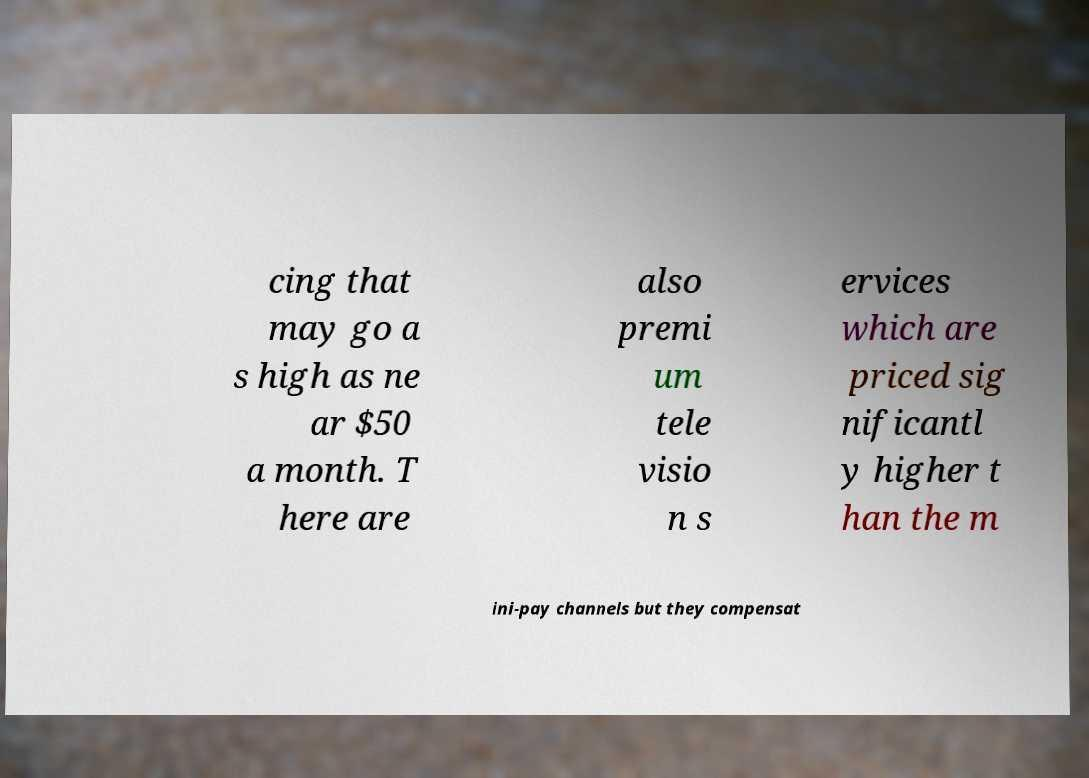Could you assist in decoding the text presented in this image and type it out clearly? cing that may go a s high as ne ar $50 a month. T here are also premi um tele visio n s ervices which are priced sig nificantl y higher t han the m ini-pay channels but they compensat 